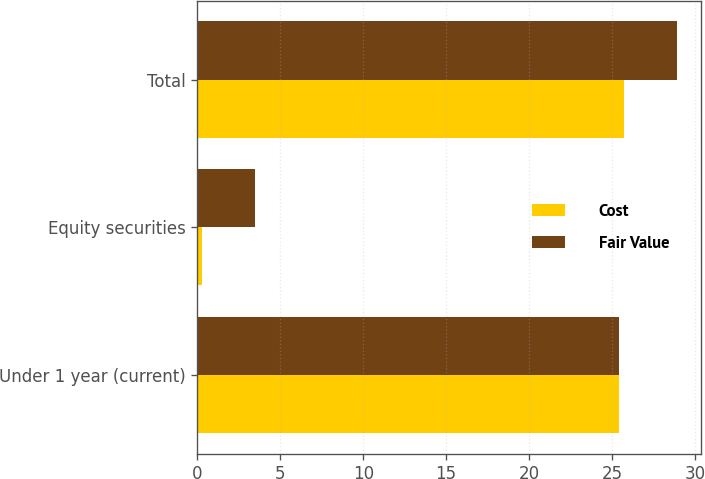Convert chart. <chart><loc_0><loc_0><loc_500><loc_500><stacked_bar_chart><ecel><fcel>Under 1 year (current)<fcel>Equity securities<fcel>Total<nl><fcel>Cost<fcel>25.4<fcel>0.3<fcel>25.7<nl><fcel>Fair Value<fcel>25.4<fcel>3.5<fcel>28.9<nl></chart> 